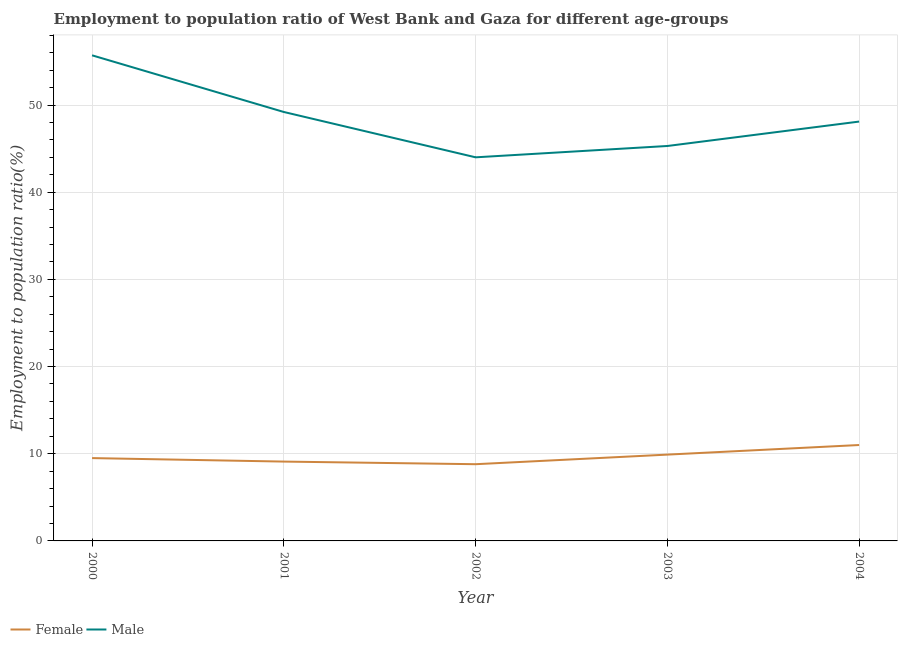How many different coloured lines are there?
Offer a terse response. 2. Does the line corresponding to employment to population ratio(male) intersect with the line corresponding to employment to population ratio(female)?
Provide a short and direct response. No. What is the employment to population ratio(male) in 2003?
Make the answer very short. 45.3. Across all years, what is the maximum employment to population ratio(female)?
Keep it short and to the point. 11. In which year was the employment to population ratio(female) maximum?
Provide a short and direct response. 2004. In which year was the employment to population ratio(male) minimum?
Ensure brevity in your answer.  2002. What is the total employment to population ratio(male) in the graph?
Offer a very short reply. 242.3. What is the difference between the employment to population ratio(female) in 2003 and that in 2004?
Offer a terse response. -1.1. What is the difference between the employment to population ratio(female) in 2003 and the employment to population ratio(male) in 2001?
Your response must be concise. -39.3. What is the average employment to population ratio(male) per year?
Provide a short and direct response. 48.46. In the year 2002, what is the difference between the employment to population ratio(male) and employment to population ratio(female)?
Your response must be concise. 35.2. In how many years, is the employment to population ratio(female) greater than 26 %?
Provide a short and direct response. 0. What is the ratio of the employment to population ratio(male) in 2000 to that in 2001?
Provide a succinct answer. 1.13. What is the difference between the highest and the second highest employment to population ratio(male)?
Make the answer very short. 6.5. What is the difference between the highest and the lowest employment to population ratio(male)?
Give a very brief answer. 11.7. Is the sum of the employment to population ratio(male) in 2001 and 2004 greater than the maximum employment to population ratio(female) across all years?
Your answer should be compact. Yes. Does the employment to population ratio(male) monotonically increase over the years?
Your answer should be compact. No. How many years are there in the graph?
Ensure brevity in your answer.  5. Does the graph contain grids?
Provide a succinct answer. Yes. Where does the legend appear in the graph?
Your response must be concise. Bottom left. How are the legend labels stacked?
Keep it short and to the point. Horizontal. What is the title of the graph?
Ensure brevity in your answer.  Employment to population ratio of West Bank and Gaza for different age-groups. Does "Netherlands" appear as one of the legend labels in the graph?
Keep it short and to the point. No. What is the label or title of the Y-axis?
Give a very brief answer. Employment to population ratio(%). What is the Employment to population ratio(%) of Female in 2000?
Your response must be concise. 9.5. What is the Employment to population ratio(%) of Male in 2000?
Offer a terse response. 55.7. What is the Employment to population ratio(%) in Female in 2001?
Make the answer very short. 9.1. What is the Employment to population ratio(%) of Male in 2001?
Offer a terse response. 49.2. What is the Employment to population ratio(%) in Female in 2002?
Give a very brief answer. 8.8. What is the Employment to population ratio(%) in Male in 2002?
Your answer should be very brief. 44. What is the Employment to population ratio(%) in Female in 2003?
Make the answer very short. 9.9. What is the Employment to population ratio(%) in Male in 2003?
Keep it short and to the point. 45.3. What is the Employment to population ratio(%) of Male in 2004?
Your answer should be very brief. 48.1. Across all years, what is the maximum Employment to population ratio(%) of Male?
Your response must be concise. 55.7. Across all years, what is the minimum Employment to population ratio(%) in Female?
Ensure brevity in your answer.  8.8. What is the total Employment to population ratio(%) in Female in the graph?
Offer a terse response. 48.3. What is the total Employment to population ratio(%) in Male in the graph?
Offer a very short reply. 242.3. What is the difference between the Employment to population ratio(%) in Male in 2000 and that in 2001?
Make the answer very short. 6.5. What is the difference between the Employment to population ratio(%) of Female in 2000 and that in 2003?
Ensure brevity in your answer.  -0.4. What is the difference between the Employment to population ratio(%) of Male in 2000 and that in 2003?
Keep it short and to the point. 10.4. What is the difference between the Employment to population ratio(%) in Female in 2000 and that in 2004?
Give a very brief answer. -1.5. What is the difference between the Employment to population ratio(%) in Male in 2000 and that in 2004?
Give a very brief answer. 7.6. What is the difference between the Employment to population ratio(%) of Female in 2001 and that in 2002?
Ensure brevity in your answer.  0.3. What is the difference between the Employment to population ratio(%) of Male in 2002 and that in 2004?
Your answer should be compact. -4.1. What is the difference between the Employment to population ratio(%) of Female in 2000 and the Employment to population ratio(%) of Male in 2001?
Provide a succinct answer. -39.7. What is the difference between the Employment to population ratio(%) of Female in 2000 and the Employment to population ratio(%) of Male in 2002?
Provide a short and direct response. -34.5. What is the difference between the Employment to population ratio(%) of Female in 2000 and the Employment to population ratio(%) of Male in 2003?
Your answer should be compact. -35.8. What is the difference between the Employment to population ratio(%) of Female in 2000 and the Employment to population ratio(%) of Male in 2004?
Offer a terse response. -38.6. What is the difference between the Employment to population ratio(%) of Female in 2001 and the Employment to population ratio(%) of Male in 2002?
Give a very brief answer. -34.9. What is the difference between the Employment to population ratio(%) in Female in 2001 and the Employment to population ratio(%) in Male in 2003?
Your answer should be very brief. -36.2. What is the difference between the Employment to population ratio(%) of Female in 2001 and the Employment to population ratio(%) of Male in 2004?
Give a very brief answer. -39. What is the difference between the Employment to population ratio(%) of Female in 2002 and the Employment to population ratio(%) of Male in 2003?
Your response must be concise. -36.5. What is the difference between the Employment to population ratio(%) of Female in 2002 and the Employment to population ratio(%) of Male in 2004?
Ensure brevity in your answer.  -39.3. What is the difference between the Employment to population ratio(%) of Female in 2003 and the Employment to population ratio(%) of Male in 2004?
Make the answer very short. -38.2. What is the average Employment to population ratio(%) of Female per year?
Make the answer very short. 9.66. What is the average Employment to population ratio(%) of Male per year?
Keep it short and to the point. 48.46. In the year 2000, what is the difference between the Employment to population ratio(%) of Female and Employment to population ratio(%) of Male?
Offer a very short reply. -46.2. In the year 2001, what is the difference between the Employment to population ratio(%) in Female and Employment to population ratio(%) in Male?
Your answer should be compact. -40.1. In the year 2002, what is the difference between the Employment to population ratio(%) in Female and Employment to population ratio(%) in Male?
Offer a very short reply. -35.2. In the year 2003, what is the difference between the Employment to population ratio(%) in Female and Employment to population ratio(%) in Male?
Offer a terse response. -35.4. In the year 2004, what is the difference between the Employment to population ratio(%) in Female and Employment to population ratio(%) in Male?
Keep it short and to the point. -37.1. What is the ratio of the Employment to population ratio(%) of Female in 2000 to that in 2001?
Your response must be concise. 1.04. What is the ratio of the Employment to population ratio(%) of Male in 2000 to that in 2001?
Your response must be concise. 1.13. What is the ratio of the Employment to population ratio(%) in Female in 2000 to that in 2002?
Provide a short and direct response. 1.08. What is the ratio of the Employment to population ratio(%) in Male in 2000 to that in 2002?
Provide a short and direct response. 1.27. What is the ratio of the Employment to population ratio(%) in Female in 2000 to that in 2003?
Offer a terse response. 0.96. What is the ratio of the Employment to population ratio(%) in Male in 2000 to that in 2003?
Make the answer very short. 1.23. What is the ratio of the Employment to population ratio(%) of Female in 2000 to that in 2004?
Make the answer very short. 0.86. What is the ratio of the Employment to population ratio(%) of Male in 2000 to that in 2004?
Keep it short and to the point. 1.16. What is the ratio of the Employment to population ratio(%) of Female in 2001 to that in 2002?
Give a very brief answer. 1.03. What is the ratio of the Employment to population ratio(%) of Male in 2001 to that in 2002?
Provide a short and direct response. 1.12. What is the ratio of the Employment to population ratio(%) in Female in 2001 to that in 2003?
Provide a succinct answer. 0.92. What is the ratio of the Employment to population ratio(%) of Male in 2001 to that in 2003?
Provide a succinct answer. 1.09. What is the ratio of the Employment to population ratio(%) of Female in 2001 to that in 2004?
Offer a terse response. 0.83. What is the ratio of the Employment to population ratio(%) of Male in 2001 to that in 2004?
Make the answer very short. 1.02. What is the ratio of the Employment to population ratio(%) in Female in 2002 to that in 2003?
Keep it short and to the point. 0.89. What is the ratio of the Employment to population ratio(%) of Male in 2002 to that in 2003?
Provide a succinct answer. 0.97. What is the ratio of the Employment to population ratio(%) in Male in 2002 to that in 2004?
Your answer should be very brief. 0.91. What is the ratio of the Employment to population ratio(%) of Female in 2003 to that in 2004?
Ensure brevity in your answer.  0.9. What is the ratio of the Employment to population ratio(%) of Male in 2003 to that in 2004?
Provide a short and direct response. 0.94. What is the difference between the highest and the second highest Employment to population ratio(%) of Female?
Provide a succinct answer. 1.1. What is the difference between the highest and the second highest Employment to population ratio(%) in Male?
Your answer should be compact. 6.5. What is the difference between the highest and the lowest Employment to population ratio(%) in Female?
Make the answer very short. 2.2. What is the difference between the highest and the lowest Employment to population ratio(%) in Male?
Offer a very short reply. 11.7. 